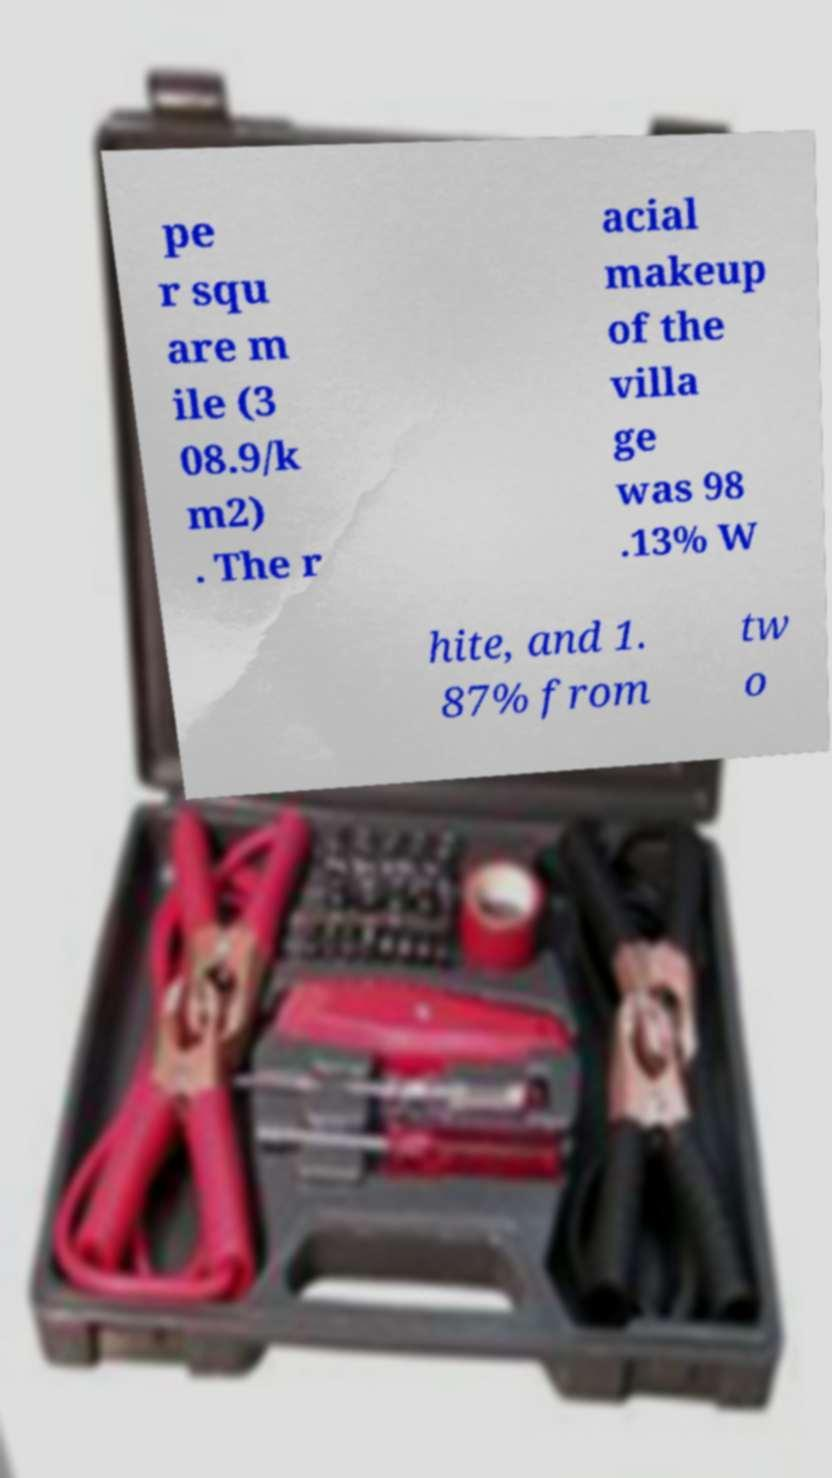For documentation purposes, I need the text within this image transcribed. Could you provide that? pe r squ are m ile (3 08.9/k m2) . The r acial makeup of the villa ge was 98 .13% W hite, and 1. 87% from tw o 